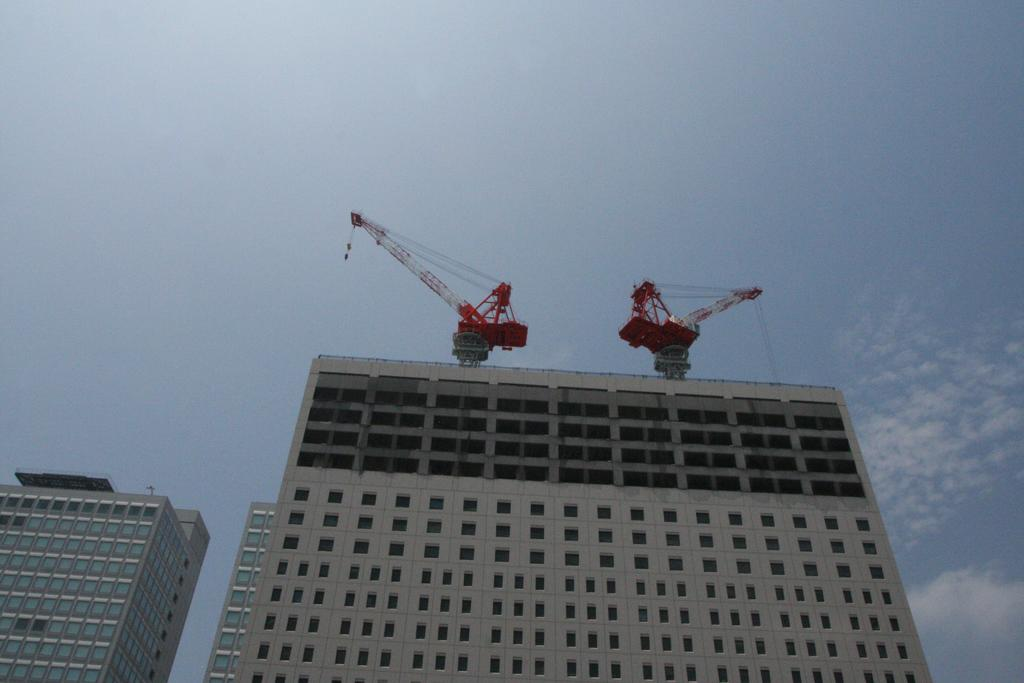What type of structures are visible in the image? There are buildings with windows in the image. What can be seen on top of one of the buildings? There are two cranes on a building in the image. What is visible in the background of the image? The sky is visible in the image. How would you describe the weather based on the appearance of the sky? The sky appears to be cloudy in the image. What type of water apparatus can be seen in the image? There is no water apparatus present in the image. 